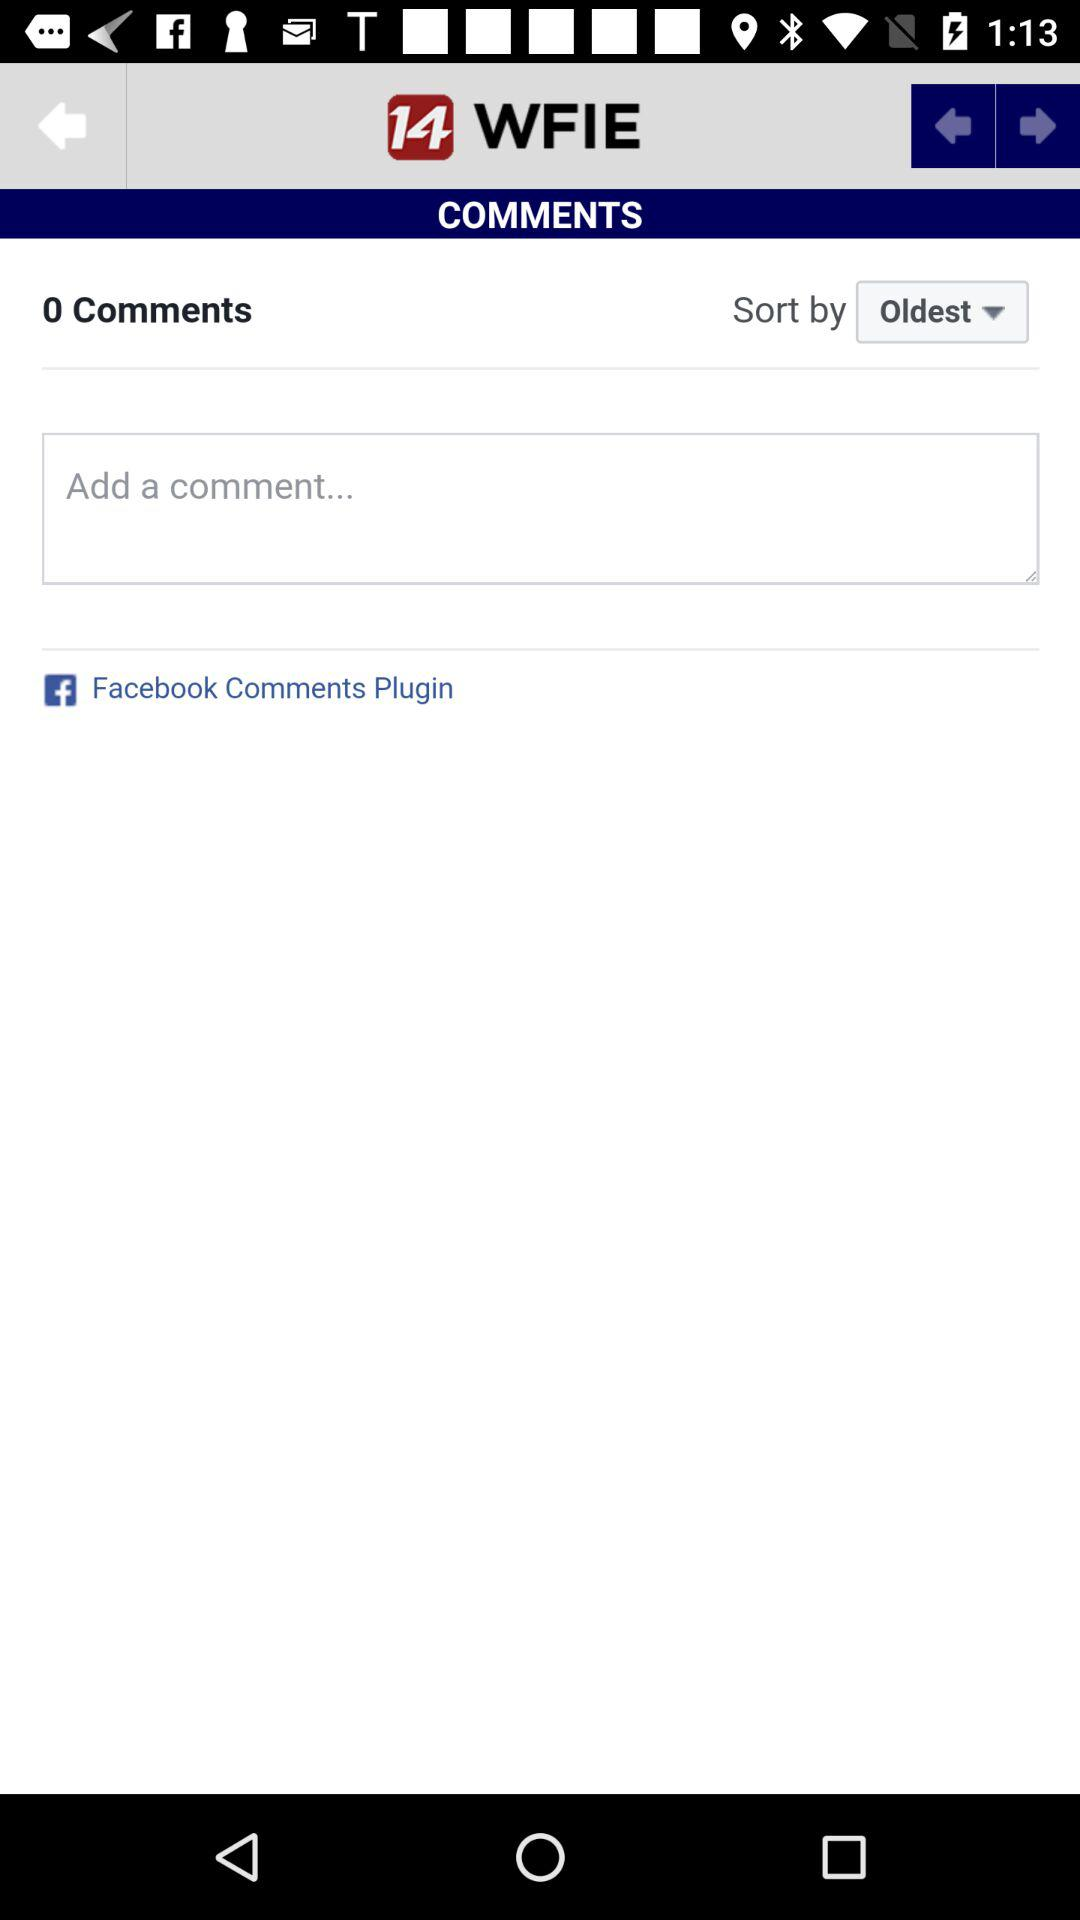Which filter is applied? The applied filter is "Oldest". 